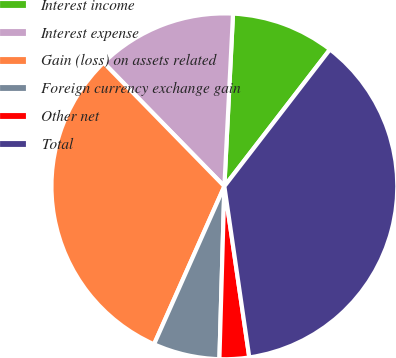Convert chart. <chart><loc_0><loc_0><loc_500><loc_500><pie_chart><fcel>Interest income<fcel>Interest expense<fcel>Gain (loss) on assets related<fcel>Foreign currency exchange gain<fcel>Other net<fcel>Total<nl><fcel>9.66%<fcel>13.11%<fcel>31.02%<fcel>6.21%<fcel>2.76%<fcel>37.24%<nl></chart> 